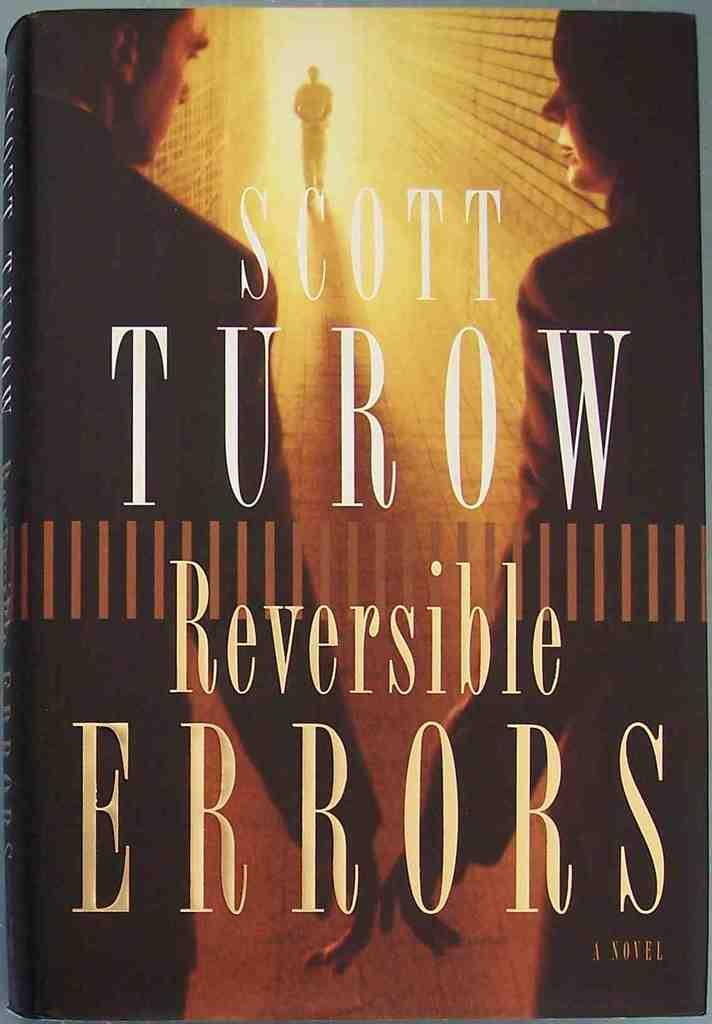<image>
Describe the image concisely. The Scott Turow book Reversible Errors is a novel. 